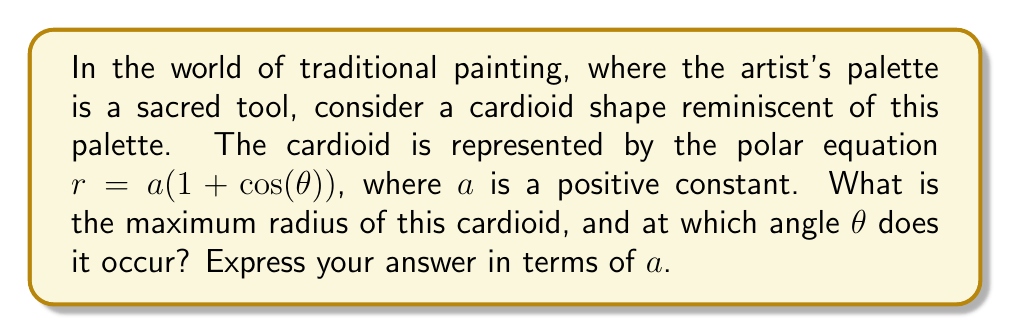Can you answer this question? To solve this problem, we'll follow these steps:

1) The radius $r$ of a cardioid is given by the equation:
   
   $r = a(1 + \cos(\theta))$

2) To find the maximum radius, we need to find the maximum value of $(1 + \cos(\theta))$. 

3) We know that the cosine function has a maximum value of 1, which occurs when $\theta = 0$ or any multiple of $2\pi$.

4) When $\cos(\theta) = 1$, the expression inside the parentheses becomes:
   
   $1 + \cos(\theta) = 1 + 1 = 2$

5) Therefore, the maximum radius occurs when:
   
   $r_{max} = a(2) = 2a$

6) This maximum radius occurs at $\theta = 0$ (or any multiple of $2\pi$).

[asy]
import graph;
size(200);
real a = 1;
real r(real t) {return a*(1+cos(t));}
draw(polargraph(r,0,2pi),rgb(0.7,0,0));
dot((2a,0),rgb(0,0.7,0));
label("$r_{max}$",(a,0),E);
draw((0,0)--(2a,0),Arrow);
[/asy]

This diagram illustrates the cardioid shape with its maximum radius highlighted.
Answer: The maximum radius of the cardioid is $2a$, occurring at $\theta = 0$ (and any multiple of $2\pi$). 